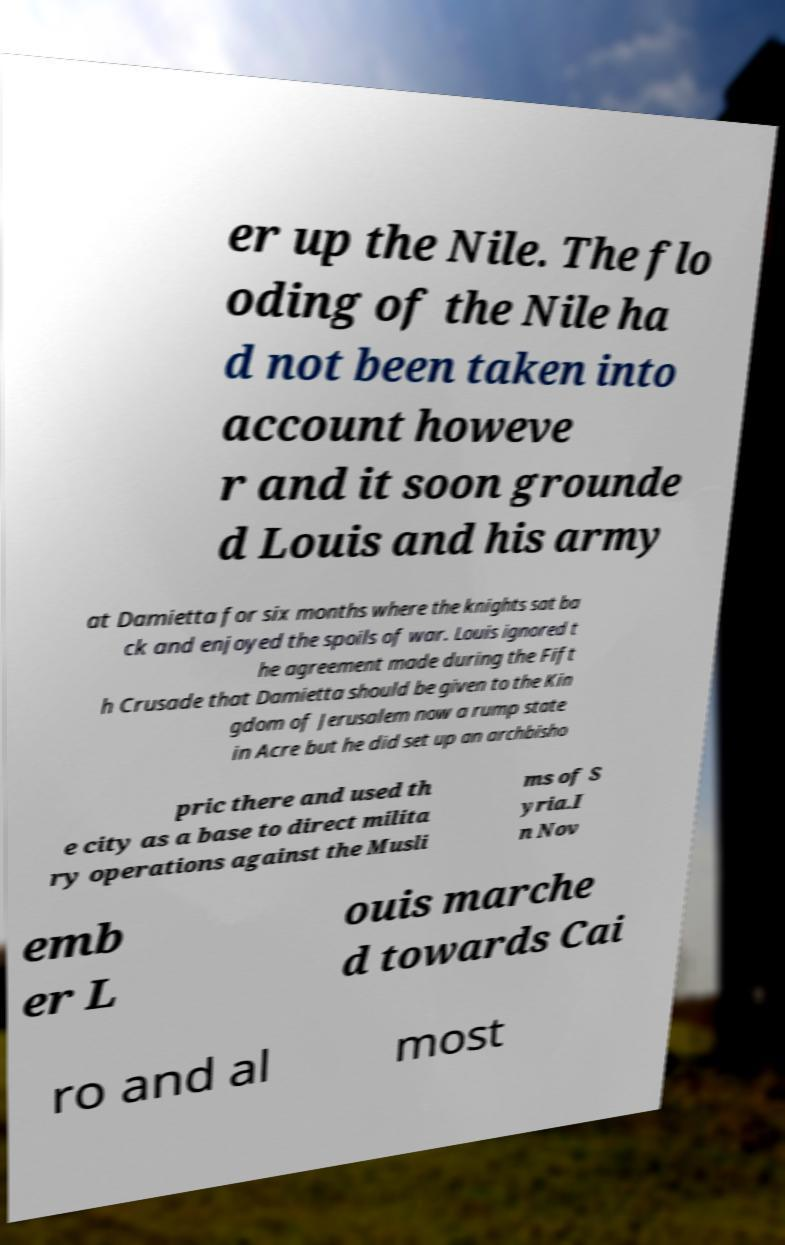I need the written content from this picture converted into text. Can you do that? er up the Nile. The flo oding of the Nile ha d not been taken into account howeve r and it soon grounde d Louis and his army at Damietta for six months where the knights sat ba ck and enjoyed the spoils of war. Louis ignored t he agreement made during the Fift h Crusade that Damietta should be given to the Kin gdom of Jerusalem now a rump state in Acre but he did set up an archbisho pric there and used th e city as a base to direct milita ry operations against the Musli ms of S yria.I n Nov emb er L ouis marche d towards Cai ro and al most 